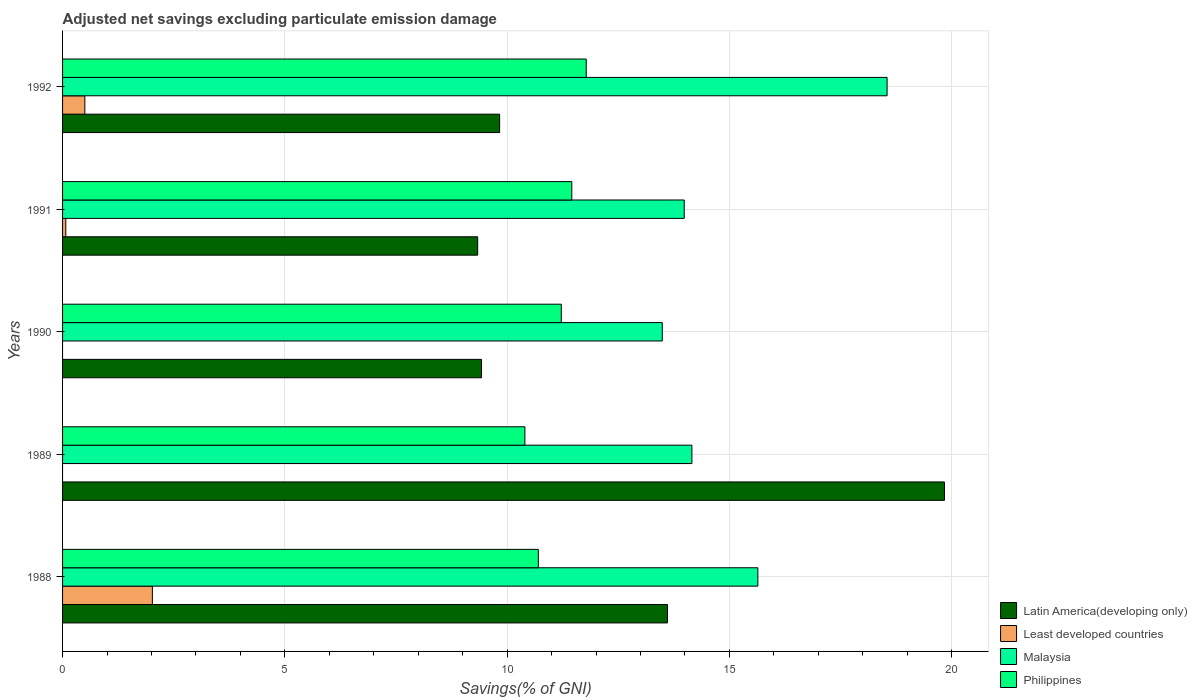How many different coloured bars are there?
Ensure brevity in your answer.  4. Are the number of bars per tick equal to the number of legend labels?
Offer a very short reply. No. What is the adjusted net savings in Least developed countries in 1989?
Provide a succinct answer. 0. Across all years, what is the maximum adjusted net savings in Least developed countries?
Give a very brief answer. 2.02. Across all years, what is the minimum adjusted net savings in Philippines?
Your answer should be compact. 10.4. What is the total adjusted net savings in Philippines in the graph?
Keep it short and to the point. 55.55. What is the difference between the adjusted net savings in Latin America(developing only) in 1990 and that in 1992?
Your response must be concise. -0.41. What is the difference between the adjusted net savings in Latin America(developing only) in 1991 and the adjusted net savings in Malaysia in 1989?
Your answer should be very brief. -4.82. What is the average adjusted net savings in Least developed countries per year?
Your response must be concise. 0.52. In the year 1989, what is the difference between the adjusted net savings in Malaysia and adjusted net savings in Philippines?
Your answer should be very brief. 3.76. In how many years, is the adjusted net savings in Malaysia greater than 5 %?
Keep it short and to the point. 5. What is the ratio of the adjusted net savings in Philippines in 1989 to that in 1990?
Your response must be concise. 0.93. Is the adjusted net savings in Latin America(developing only) in 1990 less than that in 1992?
Your answer should be compact. Yes. What is the difference between the highest and the second highest adjusted net savings in Least developed countries?
Your answer should be very brief. 1.52. What is the difference between the highest and the lowest adjusted net savings in Philippines?
Your answer should be compact. 1.38. In how many years, is the adjusted net savings in Philippines greater than the average adjusted net savings in Philippines taken over all years?
Keep it short and to the point. 3. Is it the case that in every year, the sum of the adjusted net savings in Philippines and adjusted net savings in Malaysia is greater than the sum of adjusted net savings in Least developed countries and adjusted net savings in Latin America(developing only)?
Ensure brevity in your answer.  Yes. Is it the case that in every year, the sum of the adjusted net savings in Philippines and adjusted net savings in Malaysia is greater than the adjusted net savings in Latin America(developing only)?
Make the answer very short. Yes. Does the graph contain any zero values?
Make the answer very short. Yes. Does the graph contain grids?
Give a very brief answer. Yes. What is the title of the graph?
Your answer should be compact. Adjusted net savings excluding particulate emission damage. Does "Cabo Verde" appear as one of the legend labels in the graph?
Provide a succinct answer. No. What is the label or title of the X-axis?
Your response must be concise. Savings(% of GNI). What is the Savings(% of GNI) in Latin America(developing only) in 1988?
Keep it short and to the point. 13.61. What is the Savings(% of GNI) in Least developed countries in 1988?
Ensure brevity in your answer.  2.02. What is the Savings(% of GNI) in Malaysia in 1988?
Your answer should be compact. 15.64. What is the Savings(% of GNI) of Philippines in 1988?
Provide a succinct answer. 10.7. What is the Savings(% of GNI) in Latin America(developing only) in 1989?
Offer a very short reply. 19.84. What is the Savings(% of GNI) of Malaysia in 1989?
Offer a very short reply. 14.16. What is the Savings(% of GNI) in Philippines in 1989?
Provide a short and direct response. 10.4. What is the Savings(% of GNI) in Latin America(developing only) in 1990?
Provide a succinct answer. 9.42. What is the Savings(% of GNI) in Least developed countries in 1990?
Ensure brevity in your answer.  0. What is the Savings(% of GNI) in Malaysia in 1990?
Make the answer very short. 13.49. What is the Savings(% of GNI) of Philippines in 1990?
Provide a succinct answer. 11.22. What is the Savings(% of GNI) in Latin America(developing only) in 1991?
Your answer should be very brief. 9.34. What is the Savings(% of GNI) of Least developed countries in 1991?
Ensure brevity in your answer.  0.07. What is the Savings(% of GNI) of Malaysia in 1991?
Provide a succinct answer. 13.98. What is the Savings(% of GNI) in Philippines in 1991?
Ensure brevity in your answer.  11.45. What is the Savings(% of GNI) of Latin America(developing only) in 1992?
Offer a terse response. 9.83. What is the Savings(% of GNI) in Least developed countries in 1992?
Give a very brief answer. 0.5. What is the Savings(% of GNI) of Malaysia in 1992?
Your answer should be compact. 18.55. What is the Savings(% of GNI) of Philippines in 1992?
Make the answer very short. 11.78. Across all years, what is the maximum Savings(% of GNI) in Latin America(developing only)?
Provide a succinct answer. 19.84. Across all years, what is the maximum Savings(% of GNI) in Least developed countries?
Give a very brief answer. 2.02. Across all years, what is the maximum Savings(% of GNI) in Malaysia?
Make the answer very short. 18.55. Across all years, what is the maximum Savings(% of GNI) of Philippines?
Offer a terse response. 11.78. Across all years, what is the minimum Savings(% of GNI) of Latin America(developing only)?
Offer a very short reply. 9.34. Across all years, what is the minimum Savings(% of GNI) of Least developed countries?
Your response must be concise. 0. Across all years, what is the minimum Savings(% of GNI) of Malaysia?
Make the answer very short. 13.49. Across all years, what is the minimum Savings(% of GNI) in Philippines?
Your answer should be compact. 10.4. What is the total Savings(% of GNI) of Latin America(developing only) in the graph?
Make the answer very short. 62.03. What is the total Savings(% of GNI) in Least developed countries in the graph?
Your response must be concise. 2.59. What is the total Savings(% of GNI) in Malaysia in the graph?
Offer a very short reply. 75.81. What is the total Savings(% of GNI) in Philippines in the graph?
Keep it short and to the point. 55.55. What is the difference between the Savings(% of GNI) of Latin America(developing only) in 1988 and that in 1989?
Provide a short and direct response. -6.23. What is the difference between the Savings(% of GNI) of Malaysia in 1988 and that in 1989?
Offer a terse response. 1.48. What is the difference between the Savings(% of GNI) in Philippines in 1988 and that in 1989?
Ensure brevity in your answer.  0.3. What is the difference between the Savings(% of GNI) in Latin America(developing only) in 1988 and that in 1990?
Your answer should be very brief. 4.18. What is the difference between the Savings(% of GNI) of Malaysia in 1988 and that in 1990?
Ensure brevity in your answer.  2.15. What is the difference between the Savings(% of GNI) of Philippines in 1988 and that in 1990?
Provide a short and direct response. -0.52. What is the difference between the Savings(% of GNI) in Latin America(developing only) in 1988 and that in 1991?
Offer a terse response. 4.27. What is the difference between the Savings(% of GNI) of Least developed countries in 1988 and that in 1991?
Make the answer very short. 1.95. What is the difference between the Savings(% of GNI) in Malaysia in 1988 and that in 1991?
Offer a very short reply. 1.66. What is the difference between the Savings(% of GNI) of Philippines in 1988 and that in 1991?
Offer a terse response. -0.75. What is the difference between the Savings(% of GNI) of Latin America(developing only) in 1988 and that in 1992?
Your answer should be compact. 3.78. What is the difference between the Savings(% of GNI) of Least developed countries in 1988 and that in 1992?
Keep it short and to the point. 1.52. What is the difference between the Savings(% of GNI) of Malaysia in 1988 and that in 1992?
Your response must be concise. -2.91. What is the difference between the Savings(% of GNI) in Philippines in 1988 and that in 1992?
Offer a very short reply. -1.08. What is the difference between the Savings(% of GNI) in Latin America(developing only) in 1989 and that in 1990?
Keep it short and to the point. 10.41. What is the difference between the Savings(% of GNI) in Malaysia in 1989 and that in 1990?
Your answer should be compact. 0.67. What is the difference between the Savings(% of GNI) of Philippines in 1989 and that in 1990?
Provide a short and direct response. -0.82. What is the difference between the Savings(% of GNI) in Latin America(developing only) in 1989 and that in 1991?
Give a very brief answer. 10.5. What is the difference between the Savings(% of GNI) in Malaysia in 1989 and that in 1991?
Ensure brevity in your answer.  0.17. What is the difference between the Savings(% of GNI) in Philippines in 1989 and that in 1991?
Offer a very short reply. -1.06. What is the difference between the Savings(% of GNI) in Latin America(developing only) in 1989 and that in 1992?
Ensure brevity in your answer.  10.01. What is the difference between the Savings(% of GNI) of Malaysia in 1989 and that in 1992?
Your answer should be very brief. -4.39. What is the difference between the Savings(% of GNI) in Philippines in 1989 and that in 1992?
Your answer should be very brief. -1.38. What is the difference between the Savings(% of GNI) of Latin America(developing only) in 1990 and that in 1991?
Your response must be concise. 0.09. What is the difference between the Savings(% of GNI) in Malaysia in 1990 and that in 1991?
Your response must be concise. -0.49. What is the difference between the Savings(% of GNI) of Philippines in 1990 and that in 1991?
Provide a succinct answer. -0.24. What is the difference between the Savings(% of GNI) of Latin America(developing only) in 1990 and that in 1992?
Your answer should be very brief. -0.41. What is the difference between the Savings(% of GNI) in Malaysia in 1990 and that in 1992?
Provide a short and direct response. -5.06. What is the difference between the Savings(% of GNI) in Philippines in 1990 and that in 1992?
Give a very brief answer. -0.56. What is the difference between the Savings(% of GNI) in Latin America(developing only) in 1991 and that in 1992?
Provide a succinct answer. -0.49. What is the difference between the Savings(% of GNI) in Least developed countries in 1991 and that in 1992?
Your answer should be very brief. -0.43. What is the difference between the Savings(% of GNI) in Malaysia in 1991 and that in 1992?
Keep it short and to the point. -4.56. What is the difference between the Savings(% of GNI) of Philippines in 1991 and that in 1992?
Offer a terse response. -0.32. What is the difference between the Savings(% of GNI) of Latin America(developing only) in 1988 and the Savings(% of GNI) of Malaysia in 1989?
Provide a succinct answer. -0.55. What is the difference between the Savings(% of GNI) in Latin America(developing only) in 1988 and the Savings(% of GNI) in Philippines in 1989?
Offer a very short reply. 3.21. What is the difference between the Savings(% of GNI) in Least developed countries in 1988 and the Savings(% of GNI) in Malaysia in 1989?
Provide a succinct answer. -12.14. What is the difference between the Savings(% of GNI) in Least developed countries in 1988 and the Savings(% of GNI) in Philippines in 1989?
Give a very brief answer. -8.38. What is the difference between the Savings(% of GNI) of Malaysia in 1988 and the Savings(% of GNI) of Philippines in 1989?
Make the answer very short. 5.24. What is the difference between the Savings(% of GNI) of Latin America(developing only) in 1988 and the Savings(% of GNI) of Malaysia in 1990?
Ensure brevity in your answer.  0.12. What is the difference between the Savings(% of GNI) in Latin America(developing only) in 1988 and the Savings(% of GNI) in Philippines in 1990?
Provide a short and direct response. 2.39. What is the difference between the Savings(% of GNI) of Least developed countries in 1988 and the Savings(% of GNI) of Malaysia in 1990?
Ensure brevity in your answer.  -11.47. What is the difference between the Savings(% of GNI) of Least developed countries in 1988 and the Savings(% of GNI) of Philippines in 1990?
Your answer should be compact. -9.2. What is the difference between the Savings(% of GNI) in Malaysia in 1988 and the Savings(% of GNI) in Philippines in 1990?
Offer a terse response. 4.42. What is the difference between the Savings(% of GNI) in Latin America(developing only) in 1988 and the Savings(% of GNI) in Least developed countries in 1991?
Your answer should be very brief. 13.53. What is the difference between the Savings(% of GNI) in Latin America(developing only) in 1988 and the Savings(% of GNI) in Malaysia in 1991?
Keep it short and to the point. -0.38. What is the difference between the Savings(% of GNI) of Latin America(developing only) in 1988 and the Savings(% of GNI) of Philippines in 1991?
Ensure brevity in your answer.  2.15. What is the difference between the Savings(% of GNI) in Least developed countries in 1988 and the Savings(% of GNI) in Malaysia in 1991?
Ensure brevity in your answer.  -11.96. What is the difference between the Savings(% of GNI) of Least developed countries in 1988 and the Savings(% of GNI) of Philippines in 1991?
Your answer should be very brief. -9.43. What is the difference between the Savings(% of GNI) of Malaysia in 1988 and the Savings(% of GNI) of Philippines in 1991?
Your response must be concise. 4.19. What is the difference between the Savings(% of GNI) of Latin America(developing only) in 1988 and the Savings(% of GNI) of Least developed countries in 1992?
Your response must be concise. 13.11. What is the difference between the Savings(% of GNI) of Latin America(developing only) in 1988 and the Savings(% of GNI) of Malaysia in 1992?
Keep it short and to the point. -4.94. What is the difference between the Savings(% of GNI) of Latin America(developing only) in 1988 and the Savings(% of GNI) of Philippines in 1992?
Your answer should be compact. 1.83. What is the difference between the Savings(% of GNI) of Least developed countries in 1988 and the Savings(% of GNI) of Malaysia in 1992?
Make the answer very short. -16.53. What is the difference between the Savings(% of GNI) of Least developed countries in 1988 and the Savings(% of GNI) of Philippines in 1992?
Ensure brevity in your answer.  -9.76. What is the difference between the Savings(% of GNI) in Malaysia in 1988 and the Savings(% of GNI) in Philippines in 1992?
Your answer should be very brief. 3.86. What is the difference between the Savings(% of GNI) in Latin America(developing only) in 1989 and the Savings(% of GNI) in Malaysia in 1990?
Your answer should be very brief. 6.35. What is the difference between the Savings(% of GNI) of Latin America(developing only) in 1989 and the Savings(% of GNI) of Philippines in 1990?
Ensure brevity in your answer.  8.62. What is the difference between the Savings(% of GNI) in Malaysia in 1989 and the Savings(% of GNI) in Philippines in 1990?
Make the answer very short. 2.94. What is the difference between the Savings(% of GNI) of Latin America(developing only) in 1989 and the Savings(% of GNI) of Least developed countries in 1991?
Provide a short and direct response. 19.76. What is the difference between the Savings(% of GNI) in Latin America(developing only) in 1989 and the Savings(% of GNI) in Malaysia in 1991?
Your response must be concise. 5.85. What is the difference between the Savings(% of GNI) of Latin America(developing only) in 1989 and the Savings(% of GNI) of Philippines in 1991?
Provide a short and direct response. 8.38. What is the difference between the Savings(% of GNI) in Malaysia in 1989 and the Savings(% of GNI) in Philippines in 1991?
Make the answer very short. 2.7. What is the difference between the Savings(% of GNI) in Latin America(developing only) in 1989 and the Savings(% of GNI) in Least developed countries in 1992?
Your response must be concise. 19.34. What is the difference between the Savings(% of GNI) of Latin America(developing only) in 1989 and the Savings(% of GNI) of Malaysia in 1992?
Your response must be concise. 1.29. What is the difference between the Savings(% of GNI) of Latin America(developing only) in 1989 and the Savings(% of GNI) of Philippines in 1992?
Offer a very short reply. 8.06. What is the difference between the Savings(% of GNI) in Malaysia in 1989 and the Savings(% of GNI) in Philippines in 1992?
Offer a very short reply. 2.38. What is the difference between the Savings(% of GNI) of Latin America(developing only) in 1990 and the Savings(% of GNI) of Least developed countries in 1991?
Offer a terse response. 9.35. What is the difference between the Savings(% of GNI) of Latin America(developing only) in 1990 and the Savings(% of GNI) of Malaysia in 1991?
Keep it short and to the point. -4.56. What is the difference between the Savings(% of GNI) of Latin America(developing only) in 1990 and the Savings(% of GNI) of Philippines in 1991?
Offer a terse response. -2.03. What is the difference between the Savings(% of GNI) of Malaysia in 1990 and the Savings(% of GNI) of Philippines in 1991?
Give a very brief answer. 2.04. What is the difference between the Savings(% of GNI) in Latin America(developing only) in 1990 and the Savings(% of GNI) in Least developed countries in 1992?
Give a very brief answer. 8.92. What is the difference between the Savings(% of GNI) in Latin America(developing only) in 1990 and the Savings(% of GNI) in Malaysia in 1992?
Ensure brevity in your answer.  -9.12. What is the difference between the Savings(% of GNI) in Latin America(developing only) in 1990 and the Savings(% of GNI) in Philippines in 1992?
Keep it short and to the point. -2.36. What is the difference between the Savings(% of GNI) in Malaysia in 1990 and the Savings(% of GNI) in Philippines in 1992?
Ensure brevity in your answer.  1.71. What is the difference between the Savings(% of GNI) in Latin America(developing only) in 1991 and the Savings(% of GNI) in Least developed countries in 1992?
Provide a succinct answer. 8.84. What is the difference between the Savings(% of GNI) of Latin America(developing only) in 1991 and the Savings(% of GNI) of Malaysia in 1992?
Your response must be concise. -9.21. What is the difference between the Savings(% of GNI) in Latin America(developing only) in 1991 and the Savings(% of GNI) in Philippines in 1992?
Give a very brief answer. -2.44. What is the difference between the Savings(% of GNI) in Least developed countries in 1991 and the Savings(% of GNI) in Malaysia in 1992?
Your response must be concise. -18.47. What is the difference between the Savings(% of GNI) of Least developed countries in 1991 and the Savings(% of GNI) of Philippines in 1992?
Keep it short and to the point. -11.71. What is the difference between the Savings(% of GNI) in Malaysia in 1991 and the Savings(% of GNI) in Philippines in 1992?
Your response must be concise. 2.2. What is the average Savings(% of GNI) of Latin America(developing only) per year?
Keep it short and to the point. 12.41. What is the average Savings(% of GNI) of Least developed countries per year?
Offer a very short reply. 0.52. What is the average Savings(% of GNI) in Malaysia per year?
Give a very brief answer. 15.16. What is the average Savings(% of GNI) of Philippines per year?
Make the answer very short. 11.11. In the year 1988, what is the difference between the Savings(% of GNI) of Latin America(developing only) and Savings(% of GNI) of Least developed countries?
Ensure brevity in your answer.  11.59. In the year 1988, what is the difference between the Savings(% of GNI) in Latin America(developing only) and Savings(% of GNI) in Malaysia?
Ensure brevity in your answer.  -2.03. In the year 1988, what is the difference between the Savings(% of GNI) of Latin America(developing only) and Savings(% of GNI) of Philippines?
Offer a terse response. 2.9. In the year 1988, what is the difference between the Savings(% of GNI) in Least developed countries and Savings(% of GNI) in Malaysia?
Ensure brevity in your answer.  -13.62. In the year 1988, what is the difference between the Savings(% of GNI) in Least developed countries and Savings(% of GNI) in Philippines?
Your answer should be compact. -8.68. In the year 1988, what is the difference between the Savings(% of GNI) of Malaysia and Savings(% of GNI) of Philippines?
Ensure brevity in your answer.  4.94. In the year 1989, what is the difference between the Savings(% of GNI) in Latin America(developing only) and Savings(% of GNI) in Malaysia?
Your answer should be very brief. 5.68. In the year 1989, what is the difference between the Savings(% of GNI) of Latin America(developing only) and Savings(% of GNI) of Philippines?
Your answer should be very brief. 9.44. In the year 1989, what is the difference between the Savings(% of GNI) in Malaysia and Savings(% of GNI) in Philippines?
Ensure brevity in your answer.  3.76. In the year 1990, what is the difference between the Savings(% of GNI) of Latin America(developing only) and Savings(% of GNI) of Malaysia?
Keep it short and to the point. -4.07. In the year 1990, what is the difference between the Savings(% of GNI) of Latin America(developing only) and Savings(% of GNI) of Philippines?
Your answer should be compact. -1.79. In the year 1990, what is the difference between the Savings(% of GNI) in Malaysia and Savings(% of GNI) in Philippines?
Offer a very short reply. 2.27. In the year 1991, what is the difference between the Savings(% of GNI) in Latin America(developing only) and Savings(% of GNI) in Least developed countries?
Provide a succinct answer. 9.26. In the year 1991, what is the difference between the Savings(% of GNI) of Latin America(developing only) and Savings(% of GNI) of Malaysia?
Keep it short and to the point. -4.65. In the year 1991, what is the difference between the Savings(% of GNI) of Latin America(developing only) and Savings(% of GNI) of Philippines?
Ensure brevity in your answer.  -2.12. In the year 1991, what is the difference between the Savings(% of GNI) of Least developed countries and Savings(% of GNI) of Malaysia?
Give a very brief answer. -13.91. In the year 1991, what is the difference between the Savings(% of GNI) of Least developed countries and Savings(% of GNI) of Philippines?
Provide a succinct answer. -11.38. In the year 1991, what is the difference between the Savings(% of GNI) in Malaysia and Savings(% of GNI) in Philippines?
Your response must be concise. 2.53. In the year 1992, what is the difference between the Savings(% of GNI) in Latin America(developing only) and Savings(% of GNI) in Least developed countries?
Offer a very short reply. 9.33. In the year 1992, what is the difference between the Savings(% of GNI) of Latin America(developing only) and Savings(% of GNI) of Malaysia?
Offer a very short reply. -8.72. In the year 1992, what is the difference between the Savings(% of GNI) of Latin America(developing only) and Savings(% of GNI) of Philippines?
Offer a terse response. -1.95. In the year 1992, what is the difference between the Savings(% of GNI) in Least developed countries and Savings(% of GNI) in Malaysia?
Offer a very short reply. -18.04. In the year 1992, what is the difference between the Savings(% of GNI) in Least developed countries and Savings(% of GNI) in Philippines?
Your answer should be compact. -11.28. In the year 1992, what is the difference between the Savings(% of GNI) of Malaysia and Savings(% of GNI) of Philippines?
Your answer should be compact. 6.77. What is the ratio of the Savings(% of GNI) in Latin America(developing only) in 1988 to that in 1989?
Keep it short and to the point. 0.69. What is the ratio of the Savings(% of GNI) in Malaysia in 1988 to that in 1989?
Keep it short and to the point. 1.1. What is the ratio of the Savings(% of GNI) of Philippines in 1988 to that in 1989?
Give a very brief answer. 1.03. What is the ratio of the Savings(% of GNI) of Latin America(developing only) in 1988 to that in 1990?
Make the answer very short. 1.44. What is the ratio of the Savings(% of GNI) in Malaysia in 1988 to that in 1990?
Offer a very short reply. 1.16. What is the ratio of the Savings(% of GNI) in Philippines in 1988 to that in 1990?
Provide a succinct answer. 0.95. What is the ratio of the Savings(% of GNI) in Latin America(developing only) in 1988 to that in 1991?
Provide a succinct answer. 1.46. What is the ratio of the Savings(% of GNI) of Least developed countries in 1988 to that in 1991?
Provide a succinct answer. 27.86. What is the ratio of the Savings(% of GNI) in Malaysia in 1988 to that in 1991?
Your answer should be very brief. 1.12. What is the ratio of the Savings(% of GNI) in Philippines in 1988 to that in 1991?
Ensure brevity in your answer.  0.93. What is the ratio of the Savings(% of GNI) of Latin America(developing only) in 1988 to that in 1992?
Your answer should be very brief. 1.38. What is the ratio of the Savings(% of GNI) in Least developed countries in 1988 to that in 1992?
Keep it short and to the point. 4.03. What is the ratio of the Savings(% of GNI) of Malaysia in 1988 to that in 1992?
Keep it short and to the point. 0.84. What is the ratio of the Savings(% of GNI) in Philippines in 1988 to that in 1992?
Offer a very short reply. 0.91. What is the ratio of the Savings(% of GNI) in Latin America(developing only) in 1989 to that in 1990?
Offer a very short reply. 2.1. What is the ratio of the Savings(% of GNI) of Malaysia in 1989 to that in 1990?
Your answer should be very brief. 1.05. What is the ratio of the Savings(% of GNI) of Philippines in 1989 to that in 1990?
Give a very brief answer. 0.93. What is the ratio of the Savings(% of GNI) of Latin America(developing only) in 1989 to that in 1991?
Your response must be concise. 2.12. What is the ratio of the Savings(% of GNI) in Malaysia in 1989 to that in 1991?
Your answer should be compact. 1.01. What is the ratio of the Savings(% of GNI) in Philippines in 1989 to that in 1991?
Offer a terse response. 0.91. What is the ratio of the Savings(% of GNI) in Latin America(developing only) in 1989 to that in 1992?
Your answer should be compact. 2.02. What is the ratio of the Savings(% of GNI) of Malaysia in 1989 to that in 1992?
Ensure brevity in your answer.  0.76. What is the ratio of the Savings(% of GNI) in Philippines in 1989 to that in 1992?
Give a very brief answer. 0.88. What is the ratio of the Savings(% of GNI) in Latin America(developing only) in 1990 to that in 1991?
Offer a terse response. 1.01. What is the ratio of the Savings(% of GNI) of Malaysia in 1990 to that in 1991?
Your response must be concise. 0.96. What is the ratio of the Savings(% of GNI) in Philippines in 1990 to that in 1991?
Your answer should be very brief. 0.98. What is the ratio of the Savings(% of GNI) of Latin America(developing only) in 1990 to that in 1992?
Your answer should be compact. 0.96. What is the ratio of the Savings(% of GNI) in Malaysia in 1990 to that in 1992?
Give a very brief answer. 0.73. What is the ratio of the Savings(% of GNI) of Philippines in 1990 to that in 1992?
Your answer should be very brief. 0.95. What is the ratio of the Savings(% of GNI) of Latin America(developing only) in 1991 to that in 1992?
Your answer should be compact. 0.95. What is the ratio of the Savings(% of GNI) in Least developed countries in 1991 to that in 1992?
Your answer should be compact. 0.14. What is the ratio of the Savings(% of GNI) in Malaysia in 1991 to that in 1992?
Keep it short and to the point. 0.75. What is the ratio of the Savings(% of GNI) in Philippines in 1991 to that in 1992?
Give a very brief answer. 0.97. What is the difference between the highest and the second highest Savings(% of GNI) in Latin America(developing only)?
Your answer should be very brief. 6.23. What is the difference between the highest and the second highest Savings(% of GNI) in Least developed countries?
Give a very brief answer. 1.52. What is the difference between the highest and the second highest Savings(% of GNI) of Malaysia?
Give a very brief answer. 2.91. What is the difference between the highest and the second highest Savings(% of GNI) of Philippines?
Your answer should be compact. 0.32. What is the difference between the highest and the lowest Savings(% of GNI) in Latin America(developing only)?
Provide a succinct answer. 10.5. What is the difference between the highest and the lowest Savings(% of GNI) of Least developed countries?
Offer a terse response. 2.02. What is the difference between the highest and the lowest Savings(% of GNI) of Malaysia?
Your answer should be very brief. 5.06. What is the difference between the highest and the lowest Savings(% of GNI) of Philippines?
Your response must be concise. 1.38. 